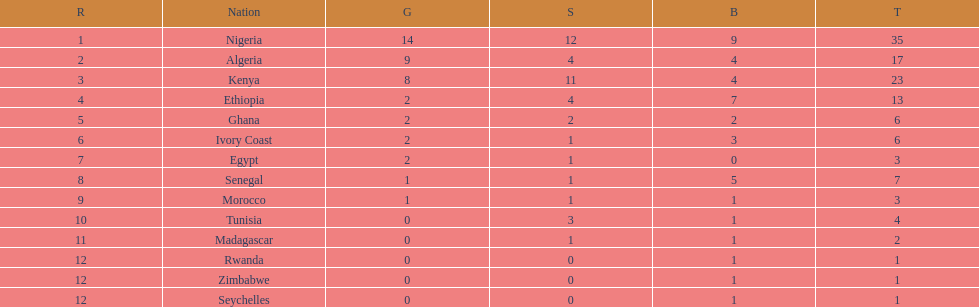How many medals did senegal win? 7. 